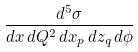<formula> <loc_0><loc_0><loc_500><loc_500>\frac { d ^ { 5 } \sigma } { d x \, d Q ^ { 2 } \, d x _ { p } \, d z _ { q } \, d \phi }</formula> 